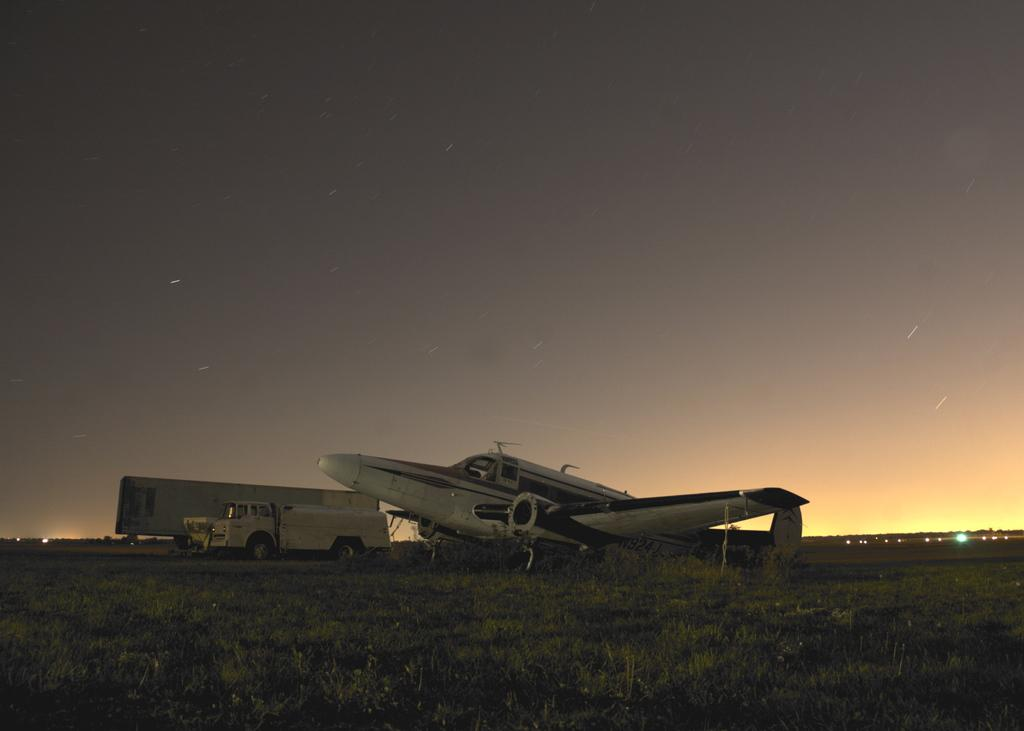What is the main subject of the image? There is an aircraft in the image. What can be seen below the aircraft? The ground is visible in the image. What type of vegetation is present on the ground? There is grass on the ground. What else can be seen in the background of the image? There are vehicles in the background of the image. Reasoning: Let' Let's think step by step in order to produce the conversation. We start by identifying the main subject of the image, which is the aircraft. Then, we describe the ground and the type of vegetation present on it, which is grass. Finally, we mention the vehicles in the background to provide a more complete description of the image. Absurd Question/Answer: What color is the team's coat in the image? There is no team or coat present in the image. How does the roll of paper move in the image? There is no roll of paper present in the image. 